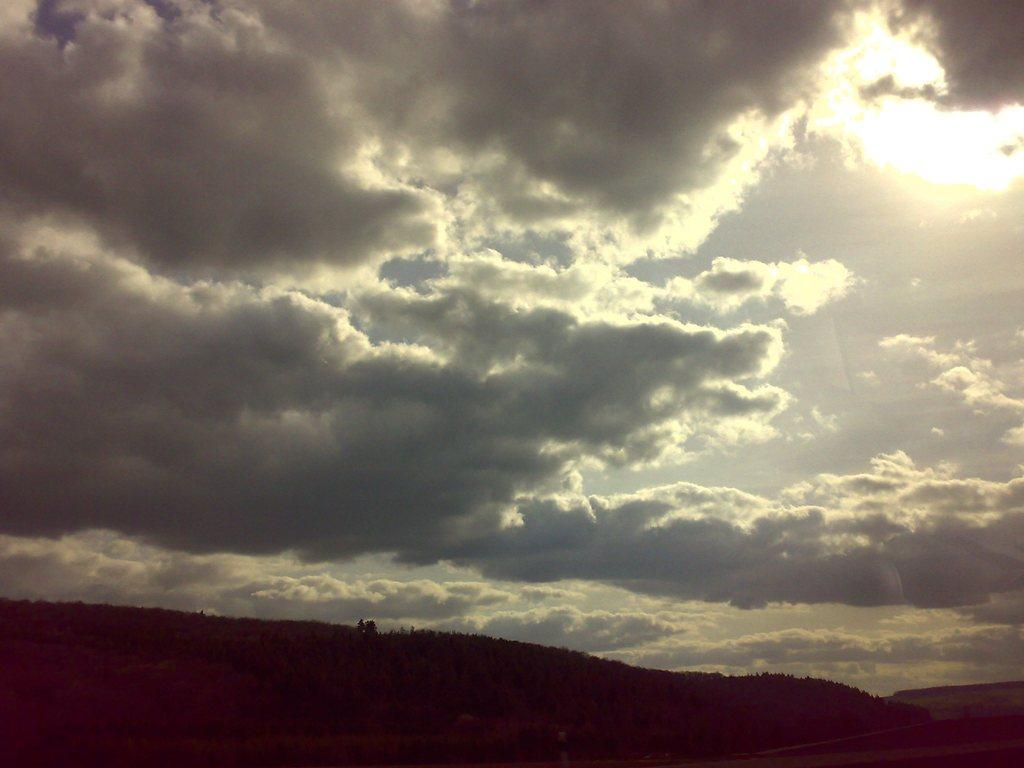What is the main feature in the center of the image? There are trees in the center of the image. How would you describe the sky in the image? The sky is cloudy in the image. What type of prose can be seen written on the arm of the person in the image? There is no person or writing present in the image; it features trees and a cloudy sky. 